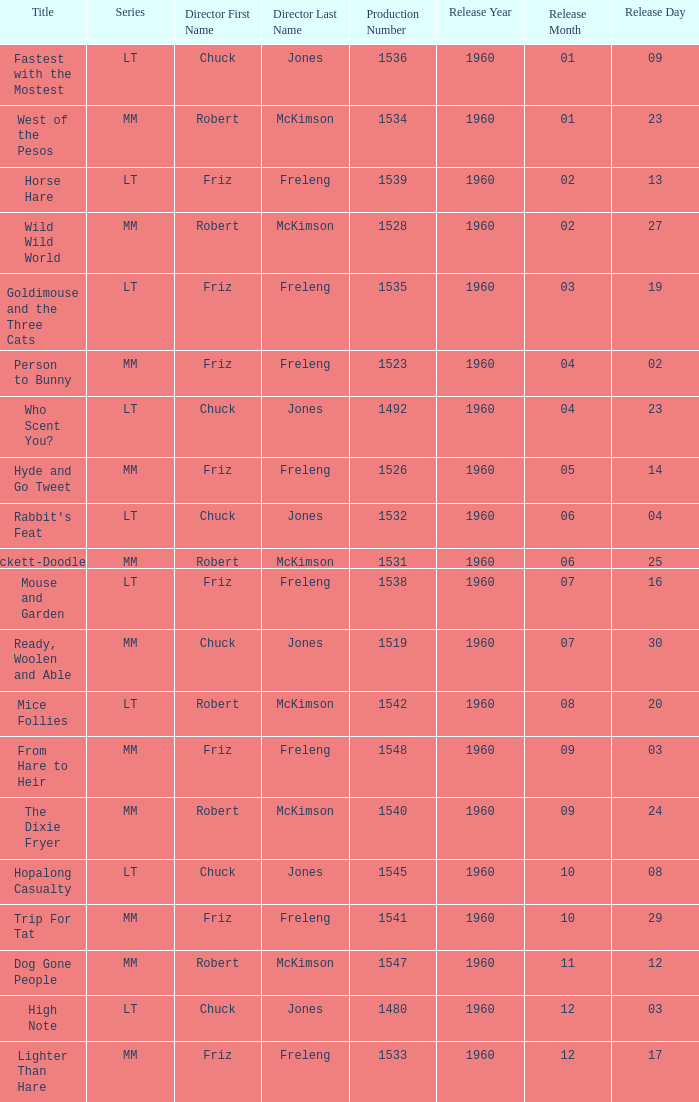What is the production number of From Hare to Heir? 1548.0. 